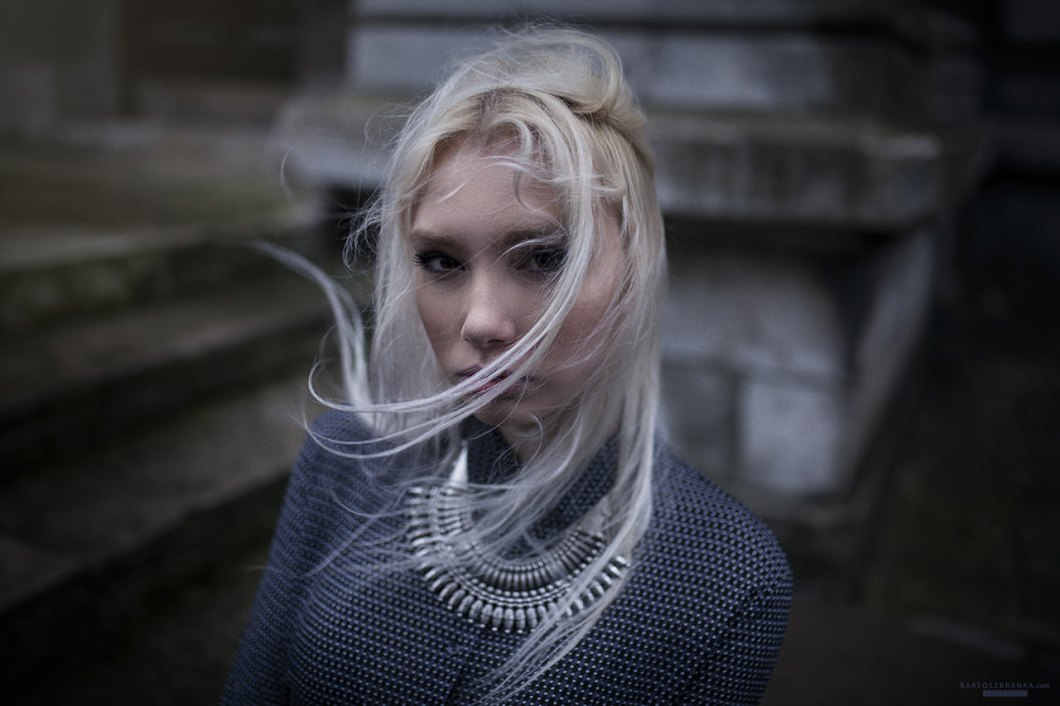Describe the woman's expression and its emotional impact on the viewer. The woman's expression seems pensive and somewhat melancholic, with a hint of introspection. Her eyes, partially veiled by her windswept hair, appear distant and reflective. This emotional depth adds layers of intrigue and invites viewers to ponder the story behind her gaze. The subtle sadness in her expression, combined with the soft, diffuse lighting and the cold, stone background, evokes a sense of solitude and contemplation, making the viewer feel both empathetic and curious. 